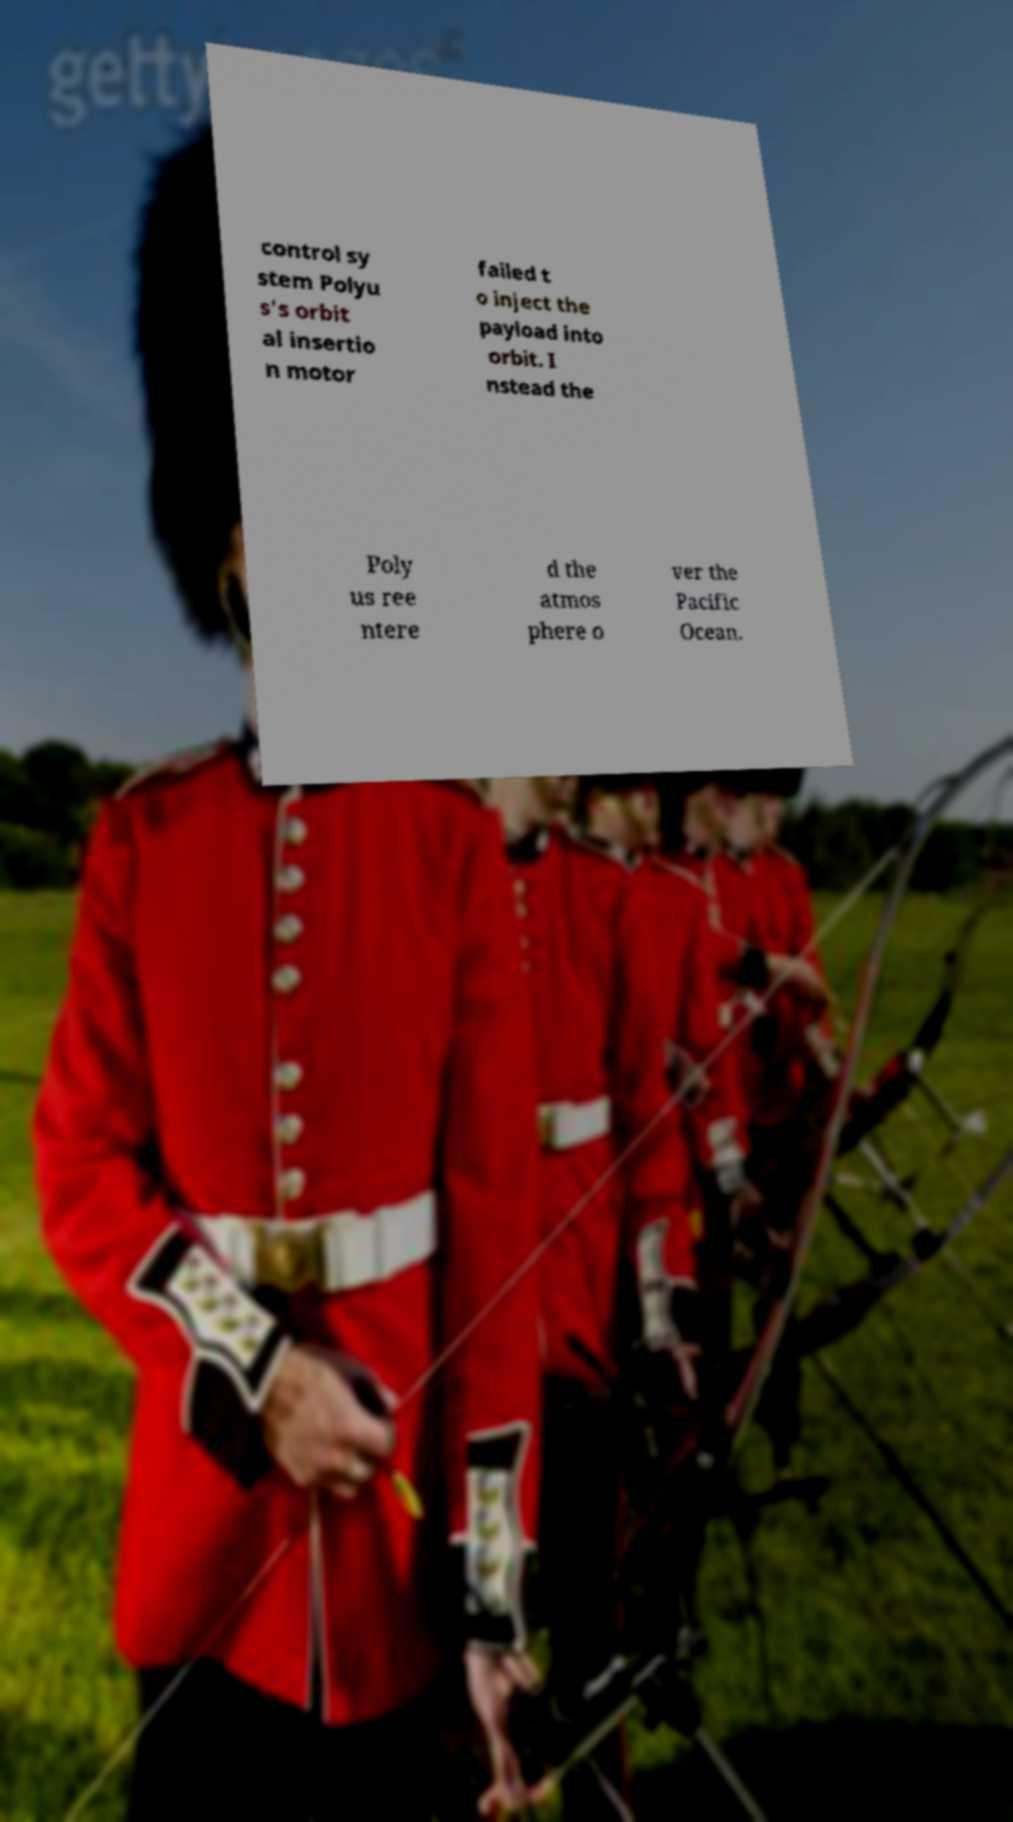Please identify and transcribe the text found in this image. control sy stem Polyu s's orbit al insertio n motor failed t o inject the payload into orbit. I nstead the Poly us ree ntere d the atmos phere o ver the Pacific Ocean. 